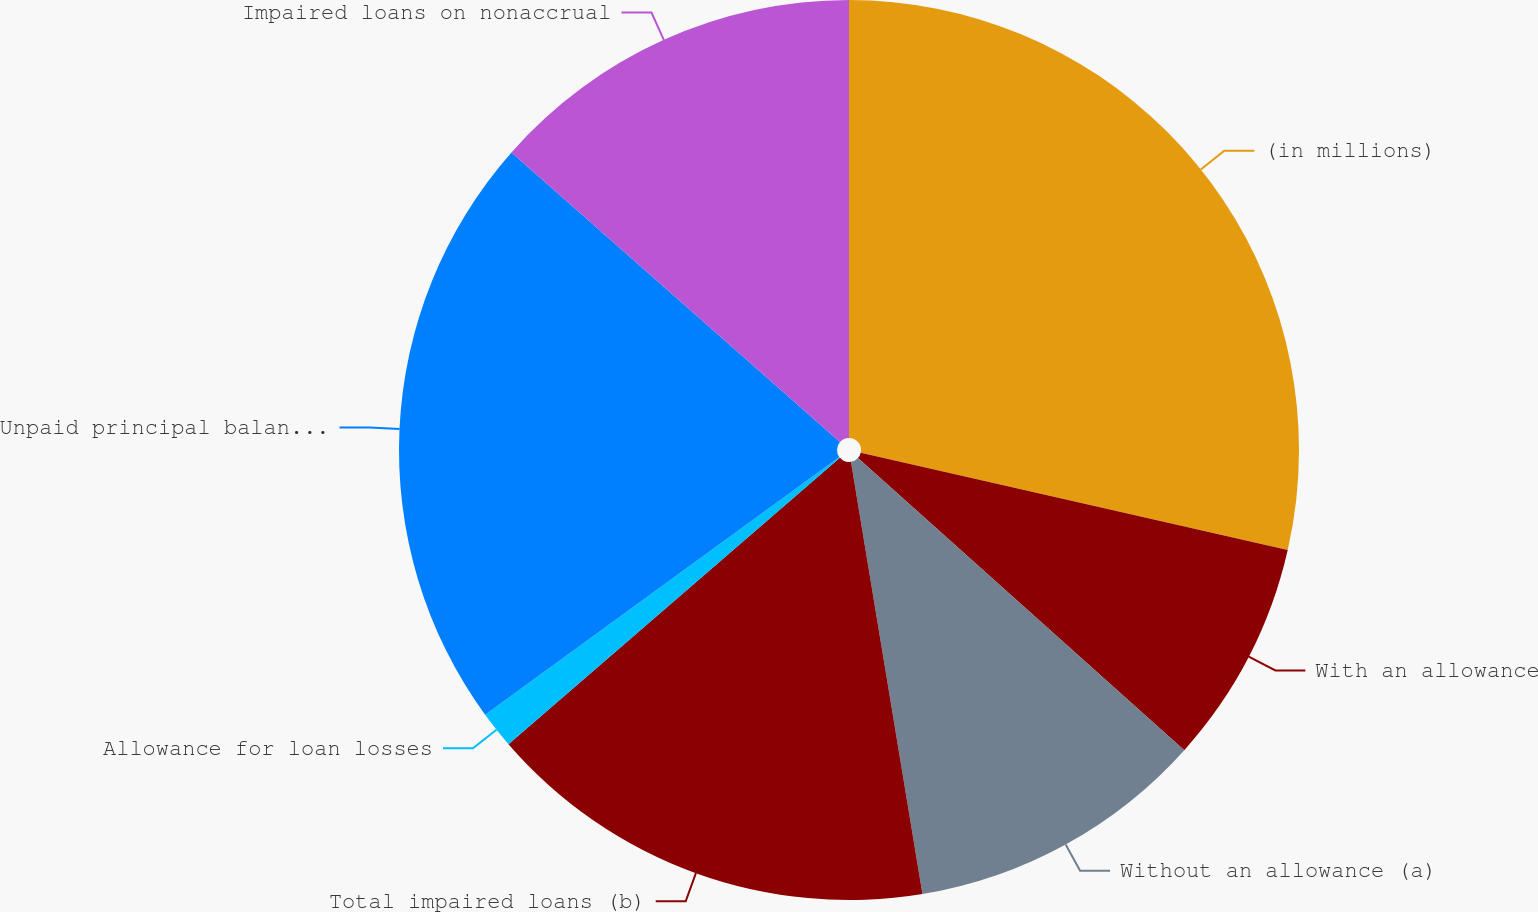<chart> <loc_0><loc_0><loc_500><loc_500><pie_chart><fcel>(in millions)<fcel>With an allowance<fcel>Without an allowance (a)<fcel>Total impaired loans (b)<fcel>Allowance for loan losses<fcel>Unpaid principal balance of<fcel>Impaired loans on nonaccrual<nl><fcel>28.57%<fcel>8.05%<fcel>10.77%<fcel>16.27%<fcel>1.33%<fcel>21.51%<fcel>13.5%<nl></chart> 